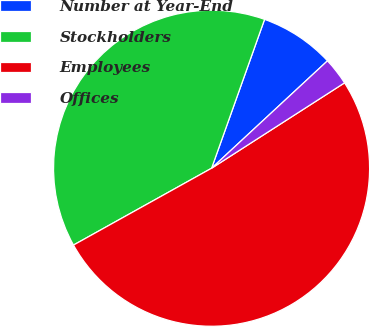Convert chart. <chart><loc_0><loc_0><loc_500><loc_500><pie_chart><fcel>Number at Year-End<fcel>Stockholders<fcel>Employees<fcel>Offices<nl><fcel>7.66%<fcel>38.52%<fcel>51.0%<fcel>2.81%<nl></chart> 